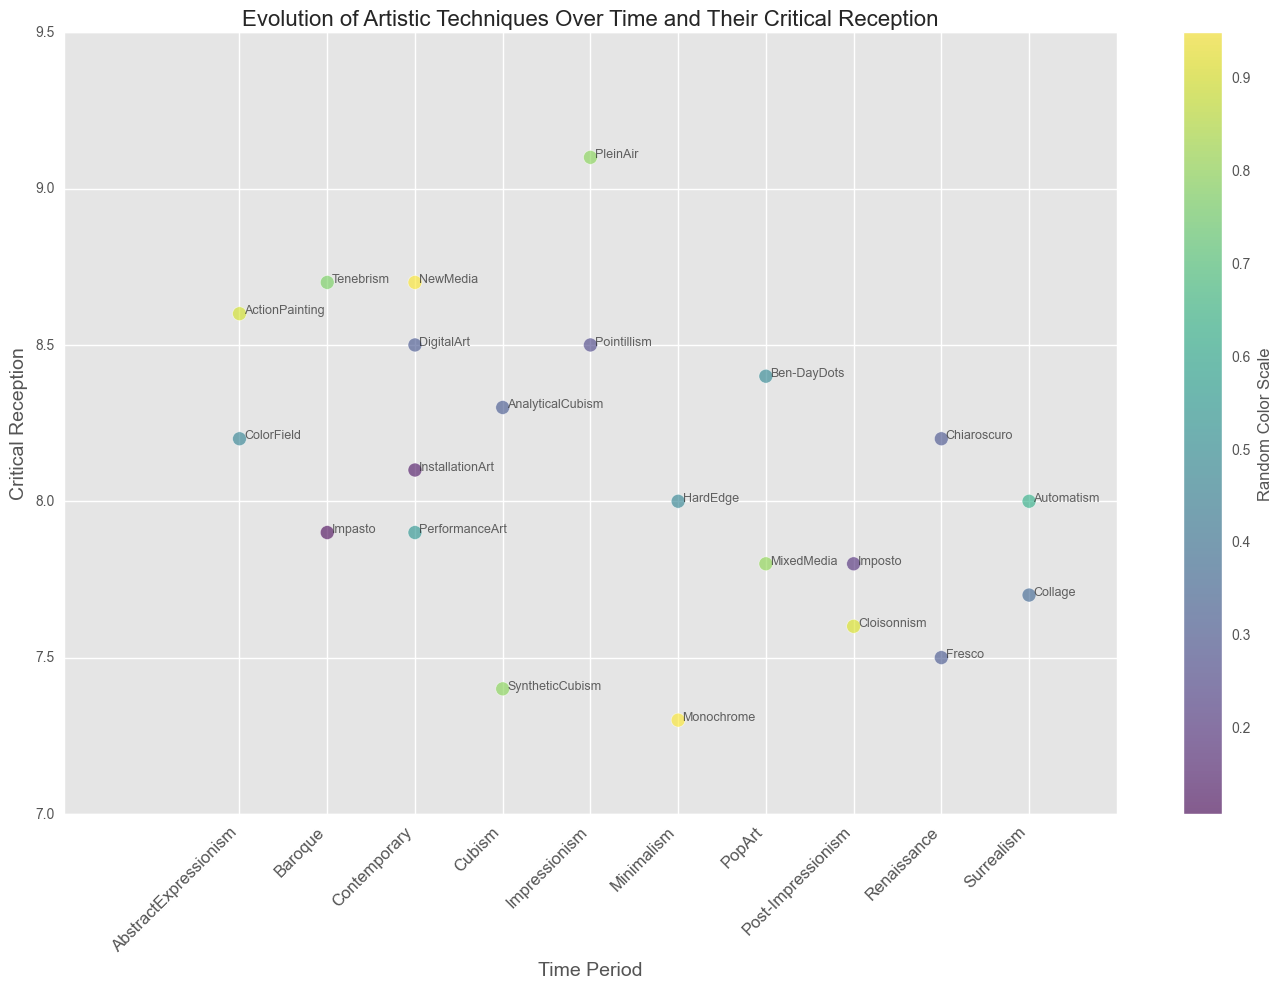What was the highest critical reception recorded for the Impressionism period? To find the highest critical reception for the Impressionism period, locate the techniques within the Impressionism time period on the x-axis and identify their critical receptions on the y-axis. PleinAir and Pointillism are the techniques in this period with receptions of 9.1 and 8.5 respectively. The highest is 9.1 for PleinAir.
Answer: 9.1 Which time period had the technique with the lowest critical reception, and what was that reception score? Examine the lowest y-axis points for each time period. The lowest reception is for Minimalism with a score of 7.3 for Monochrome.
Answer: Minimalism, 7.3 How many techniques in the Contemporary period have a critical reception of 8 or higher? Identify the techniques within the Contemporary time period on the x-axis and check their critical receptions on the y-axis. Techniques with receptions of 8 or higher include DigitalArt (8.5), NewMedia (8.7), and InstallationArt (8.1), totaling three techniques.
Answer: 3 What is the average critical reception of techniques from the Baroque period? Locate the techniques in the Baroque period and sum their critical receptions, then divide by the number of techniques. Tenebrism: 8.7, Impasto: 7.9. Average = (8.7 + 7.9)/2 = 8.3.
Answer: 8.3 Which technique has a higher critical reception: Collage or HardEdge? Compare the critical receptions of Collage (Surrealism) with a reception of 7.7 and HardEdge (Minimalism) with a reception of 8.0. HardEdge has the higher score.
Answer: HardEdge Is there a significant difference in critical reception between Pointillism and Cloisonnism? Compare their receptions: Pointillism (8.5) and Cloisonnism (7.6). Calculate the difference: 8.5 - 7.6 = 0.9, which indicates that there is a noticeable difference.
Answer: Yes, 0.9 Which technique in the Cubism period had a lower reception, AnalyticalCubism or SyntheticCubism? Compare the critical receptions of AnalyticalCubism (8.3) and SyntheticCubism (7.4). SyntheticCubism has the lower score.
Answer: SyntheticCubism What is the combined critical reception for all techniques in the Renaissance period? Sum the critical receptions of Chiaroscuro (8.2) and Fresco (7.5). Total = 8.2 + 7.5 = 15.7.
Answer: 15.7 Which time period has more techniques with a critical reception of 8 or higher: Surrealism or PopArt? Count the techniques within each period with reception scores of 8 or higher. Surrealism: Automatism (8.0); PopArt: Ben-DayDots (8.4). Each period has one technique meeting this criterion.
Answer: It's a tie, 1 each 